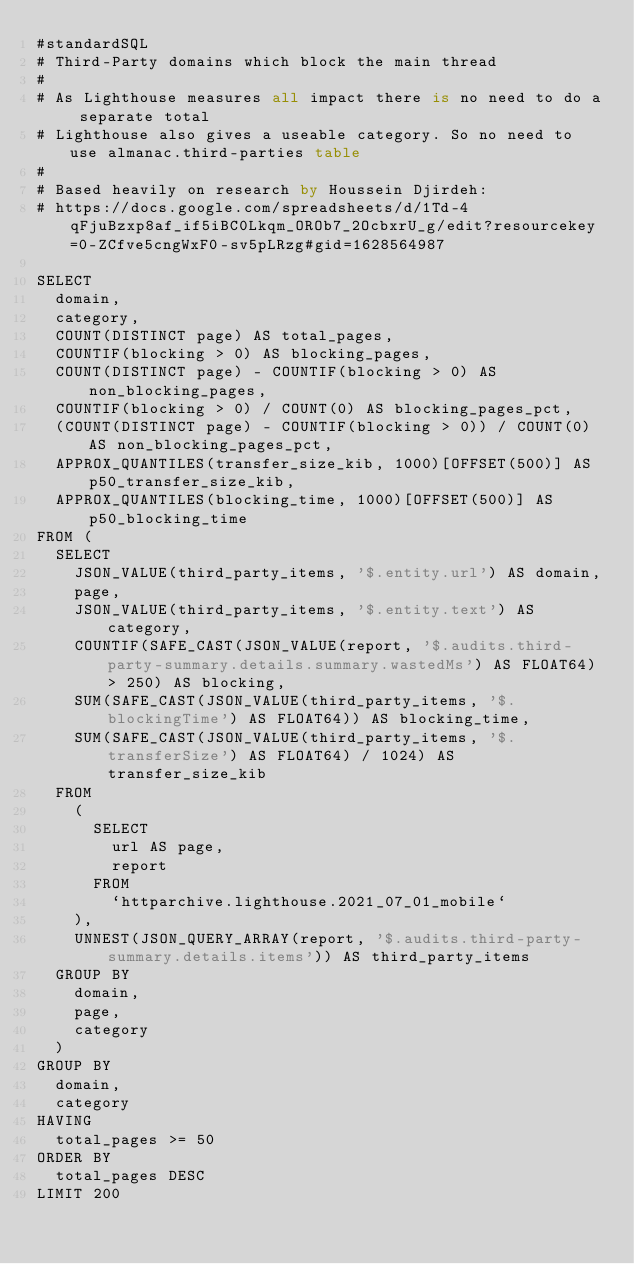Convert code to text. <code><loc_0><loc_0><loc_500><loc_500><_SQL_>#standardSQL
# Third-Party domains which block the main thread
#
# As Lighthouse measures all impact there is no need to do a separate total
# Lighthouse also gives a useable category. So no need to use almanac.third-parties table
#
# Based heavily on research by Houssein Djirdeh:
# https://docs.google.com/spreadsheets/d/1Td-4qFjuBzxp8af_if5iBC0Lkqm_OROb7_2OcbxrU_g/edit?resourcekey=0-ZCfve5cngWxF0-sv5pLRzg#gid=1628564987

SELECT
  domain,
  category,
  COUNT(DISTINCT page) AS total_pages,
  COUNTIF(blocking > 0) AS blocking_pages,
  COUNT(DISTINCT page) - COUNTIF(blocking > 0) AS non_blocking_pages,
  COUNTIF(blocking > 0) / COUNT(0) AS blocking_pages_pct,
  (COUNT(DISTINCT page) - COUNTIF(blocking > 0)) / COUNT(0) AS non_blocking_pages_pct,
  APPROX_QUANTILES(transfer_size_kib, 1000)[OFFSET(500)] AS p50_transfer_size_kib,
  APPROX_QUANTILES(blocking_time, 1000)[OFFSET(500)] AS p50_blocking_time
FROM (
  SELECT
    JSON_VALUE(third_party_items, '$.entity.url') AS domain,
    page,
    JSON_VALUE(third_party_items, '$.entity.text') AS category,
    COUNTIF(SAFE_CAST(JSON_VALUE(report, '$.audits.third-party-summary.details.summary.wastedMs') AS FLOAT64) > 250) AS blocking,
    SUM(SAFE_CAST(JSON_VALUE(third_party_items, '$.blockingTime') AS FLOAT64)) AS blocking_time,
    SUM(SAFE_CAST(JSON_VALUE(third_party_items, '$.transferSize') AS FLOAT64) / 1024) AS transfer_size_kib
  FROM
    (
      SELECT
        url AS page,
        report
      FROM
        `httparchive.lighthouse.2021_07_01_mobile`
    ),
    UNNEST(JSON_QUERY_ARRAY(report, '$.audits.third-party-summary.details.items')) AS third_party_items
  GROUP BY
    domain,
    page,
    category
  )
GROUP BY
  domain,
  category
HAVING
  total_pages >= 50
ORDER BY
  total_pages DESC
LIMIT 200
</code> 